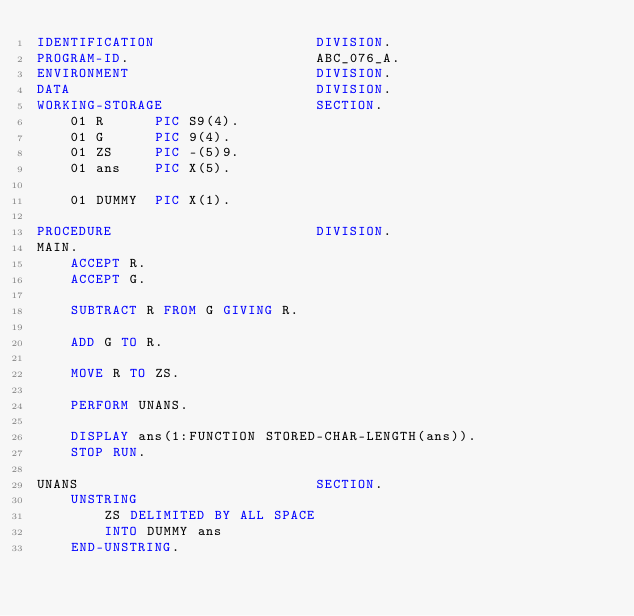Convert code to text. <code><loc_0><loc_0><loc_500><loc_500><_COBOL_>IDENTIFICATION                   DIVISION.
PROGRAM-ID.                      ABC_076_A.
ENVIRONMENT                      DIVISION.
DATA                             DIVISION.
WORKING-STORAGE                  SECTION.
    01 R      PIC S9(4).
    01 G      PIC 9(4).
    01 ZS     PIC -(5)9.
    01 ans    PIC X(5).

    01 DUMMY  PIC X(1).

PROCEDURE                        DIVISION.
MAIN.
    ACCEPT R.
    ACCEPT G.

    SUBTRACT R FROM G GIVING R.

    ADD G TO R.

    MOVE R TO ZS.

    PERFORM UNANS.

    DISPLAY ans(1:FUNCTION STORED-CHAR-LENGTH(ans)).
    STOP RUN.

UNANS                            SECTION.
    UNSTRING
        ZS DELIMITED BY ALL SPACE
        INTO DUMMY ans
    END-UNSTRING.
</code> 